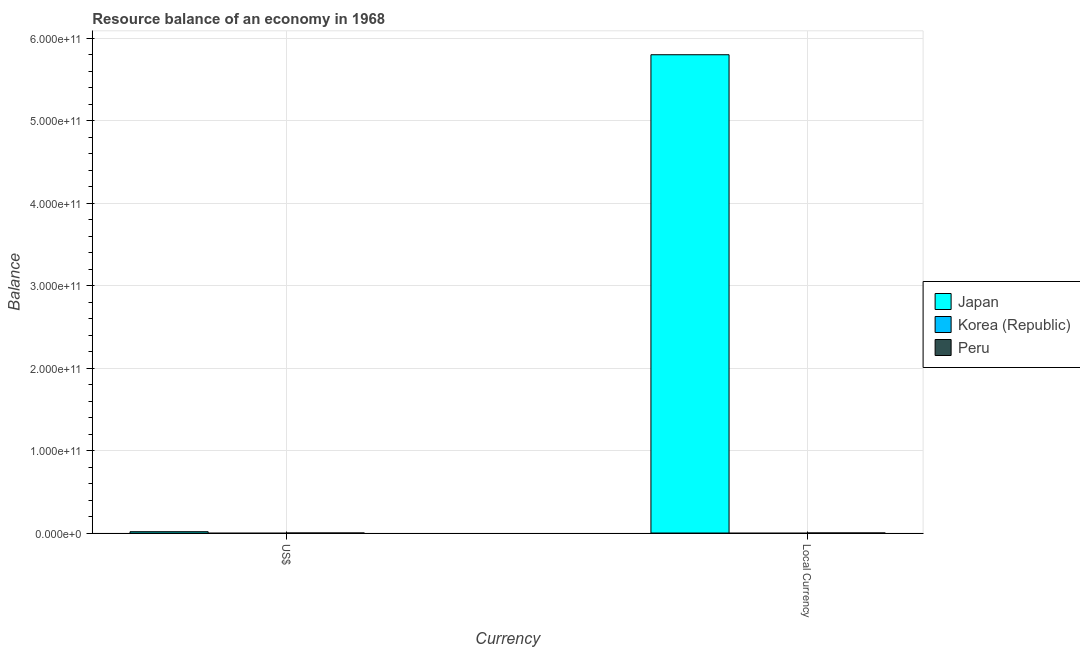Are the number of bars on each tick of the X-axis equal?
Keep it short and to the point. Yes. How many bars are there on the 1st tick from the right?
Your answer should be very brief. 1. What is the label of the 2nd group of bars from the left?
Keep it short and to the point. Local Currency. What is the resource balance in us$ in Japan?
Your response must be concise. 1.61e+09. Across all countries, what is the maximum resource balance in us$?
Provide a succinct answer. 1.61e+09. Across all countries, what is the minimum resource balance in constant us$?
Make the answer very short. 0. What is the total resource balance in constant us$ in the graph?
Your response must be concise. 5.80e+11. What is the difference between the resource balance in constant us$ in Japan and the resource balance in us$ in Peru?
Give a very brief answer. 5.80e+11. What is the average resource balance in us$ per country?
Provide a succinct answer. 5.37e+08. What is the difference between the resource balance in constant us$ and resource balance in us$ in Japan?
Make the answer very short. 5.78e+11. In how many countries, is the resource balance in constant us$ greater than 200000000000 units?
Give a very brief answer. 1. Are all the bars in the graph horizontal?
Your answer should be very brief. No. How many countries are there in the graph?
Your response must be concise. 3. What is the difference between two consecutive major ticks on the Y-axis?
Provide a short and direct response. 1.00e+11. Are the values on the major ticks of Y-axis written in scientific E-notation?
Keep it short and to the point. Yes. Does the graph contain grids?
Offer a terse response. Yes. How many legend labels are there?
Provide a short and direct response. 3. What is the title of the graph?
Your answer should be compact. Resource balance of an economy in 1968. Does "Indonesia" appear as one of the legend labels in the graph?
Keep it short and to the point. No. What is the label or title of the X-axis?
Ensure brevity in your answer.  Currency. What is the label or title of the Y-axis?
Keep it short and to the point. Balance. What is the Balance in Japan in US$?
Your response must be concise. 1.61e+09. What is the Balance of Peru in US$?
Your response must be concise. 0. What is the Balance of Japan in Local Currency?
Your answer should be compact. 5.80e+11. What is the Balance in Korea (Republic) in Local Currency?
Make the answer very short. 0. What is the Balance of Peru in Local Currency?
Ensure brevity in your answer.  0. Across all Currency, what is the maximum Balance of Japan?
Ensure brevity in your answer.  5.80e+11. Across all Currency, what is the minimum Balance of Japan?
Make the answer very short. 1.61e+09. What is the total Balance in Japan in the graph?
Your answer should be very brief. 5.81e+11. What is the total Balance of Korea (Republic) in the graph?
Make the answer very short. 0. What is the total Balance in Peru in the graph?
Your response must be concise. 0. What is the difference between the Balance in Japan in US$ and that in Local Currency?
Offer a very short reply. -5.78e+11. What is the average Balance of Japan per Currency?
Offer a terse response. 2.91e+11. What is the average Balance of Peru per Currency?
Keep it short and to the point. 0. What is the ratio of the Balance in Japan in US$ to that in Local Currency?
Ensure brevity in your answer.  0. What is the difference between the highest and the second highest Balance in Japan?
Provide a succinct answer. 5.78e+11. What is the difference between the highest and the lowest Balance of Japan?
Make the answer very short. 5.78e+11. 